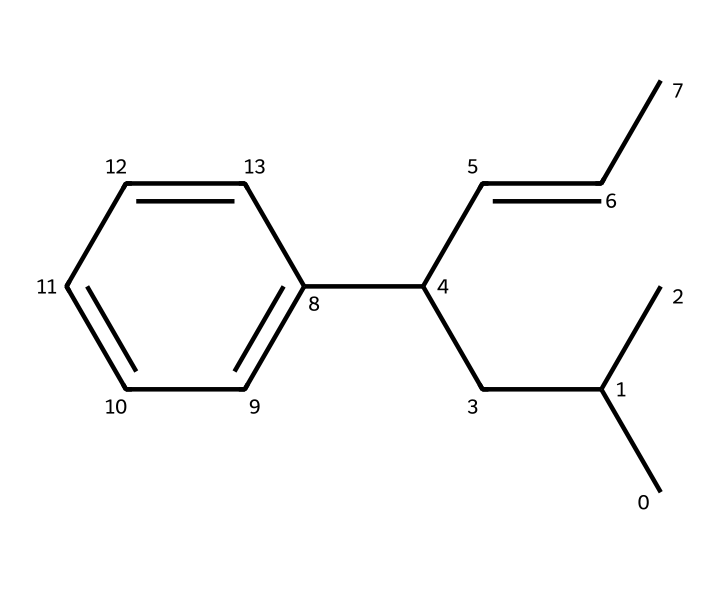What is the molecular formula of this compound? To determine the molecular formula, count the carbon and hydrogen atoms in the SMILES representation. There are 15 carbon atoms and 24 hydrogen atoms in total. Therefore, the molecular formula is C15H24.
Answer: C15H24 How many double bonds are present in this structure? Inspect the SMILES representation for any double bonds indicated by "=". There is one double bond in the structure (C=CC).
Answer: one What functional groups are present in the structure? Examine the SMILES for any distinctive characteristics that denote functional groups. This structure primarily contains hydrocarbons with no specific functional groups visible in the SMILES notation.
Answer: none What is the significance of the phenyl group in this hydrocarbon? The phenyl group (c1ccccc1) is part of the structure that can provide specific properties such as increased stability and hydrophobicity to the synthetic rubber. It enhances the performance characteristics beneficial for military applications.
Answer: increased stability Which part of this hydrocarbon contributes to its flexibility? The branched alkyl chains (CC(C)CC(C=CC)) contribute to the flexibility by creating a less rigid structure allowing for better movement, which is essential for materials used in military gear.
Answer: branched alkyl chains Is this compound saturated or unsaturated? To determine this, check for double or triple bonds. The presence of one double bond indicates that this hydrocarbon is unsaturated.
Answer: unsaturated 